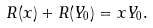<formula> <loc_0><loc_0><loc_500><loc_500>R ( x ) + R ( Y _ { 0 } ) = x Y _ { 0 } .</formula> 